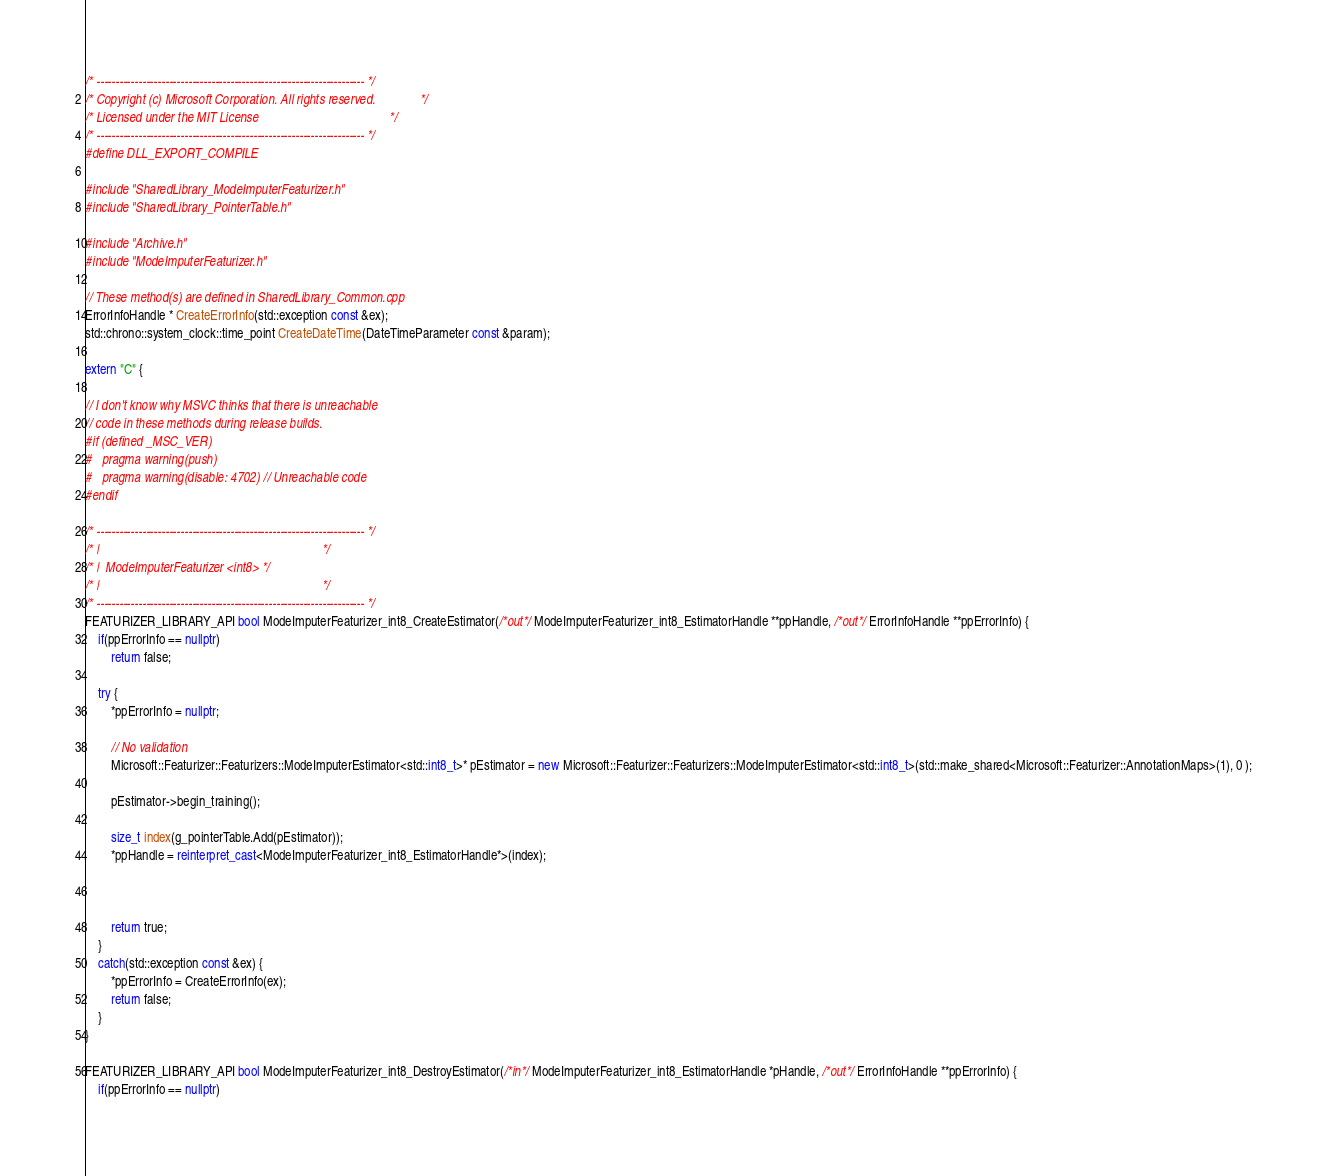<code> <loc_0><loc_0><loc_500><loc_500><_C++_>/* ---------------------------------------------------------------------- */
/* Copyright (c) Microsoft Corporation. All rights reserved.              */
/* Licensed under the MIT License                                         */
/* ---------------------------------------------------------------------- */
#define DLL_EXPORT_COMPILE

#include "SharedLibrary_ModeImputerFeaturizer.h"
#include "SharedLibrary_PointerTable.h"

#include "Archive.h"
#include "ModeImputerFeaturizer.h"

// These method(s) are defined in SharedLibrary_Common.cpp
ErrorInfoHandle * CreateErrorInfo(std::exception const &ex);
std::chrono::system_clock::time_point CreateDateTime(DateTimeParameter const &param);

extern "C" {

// I don't know why MSVC thinks that there is unreachable
// code in these methods during release builds.
#if (defined _MSC_VER)
#   pragma warning(push)
#   pragma warning(disable: 4702) // Unreachable code
#endif

/* ---------------------------------------------------------------------- */
/* |                                                                      */
/* |  ModeImputerFeaturizer <int8> */
/* |                                                                      */
/* ---------------------------------------------------------------------- */
FEATURIZER_LIBRARY_API bool ModeImputerFeaturizer_int8_CreateEstimator(/*out*/ ModeImputerFeaturizer_int8_EstimatorHandle **ppHandle, /*out*/ ErrorInfoHandle **ppErrorInfo) {
    if(ppErrorInfo == nullptr)
        return false;

    try {
        *ppErrorInfo = nullptr;

        // No validation
        Microsoft::Featurizer::Featurizers::ModeImputerEstimator<std::int8_t>* pEstimator = new Microsoft::Featurizer::Featurizers::ModeImputerEstimator<std::int8_t>(std::make_shared<Microsoft::Featurizer::AnnotationMaps>(1), 0 );

        pEstimator->begin_training();

        size_t index(g_pointerTable.Add(pEstimator));
        *ppHandle = reinterpret_cast<ModeImputerFeaturizer_int8_EstimatorHandle*>(index);


    
        return true;
    }
    catch(std::exception const &ex) {
        *ppErrorInfo = CreateErrorInfo(ex);
        return false;
    }
}

FEATURIZER_LIBRARY_API bool ModeImputerFeaturizer_int8_DestroyEstimator(/*in*/ ModeImputerFeaturizer_int8_EstimatorHandle *pHandle, /*out*/ ErrorInfoHandle **ppErrorInfo) {
    if(ppErrorInfo == nullptr)</code> 